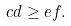<formula> <loc_0><loc_0><loc_500><loc_500>c d \geq e f .</formula> 